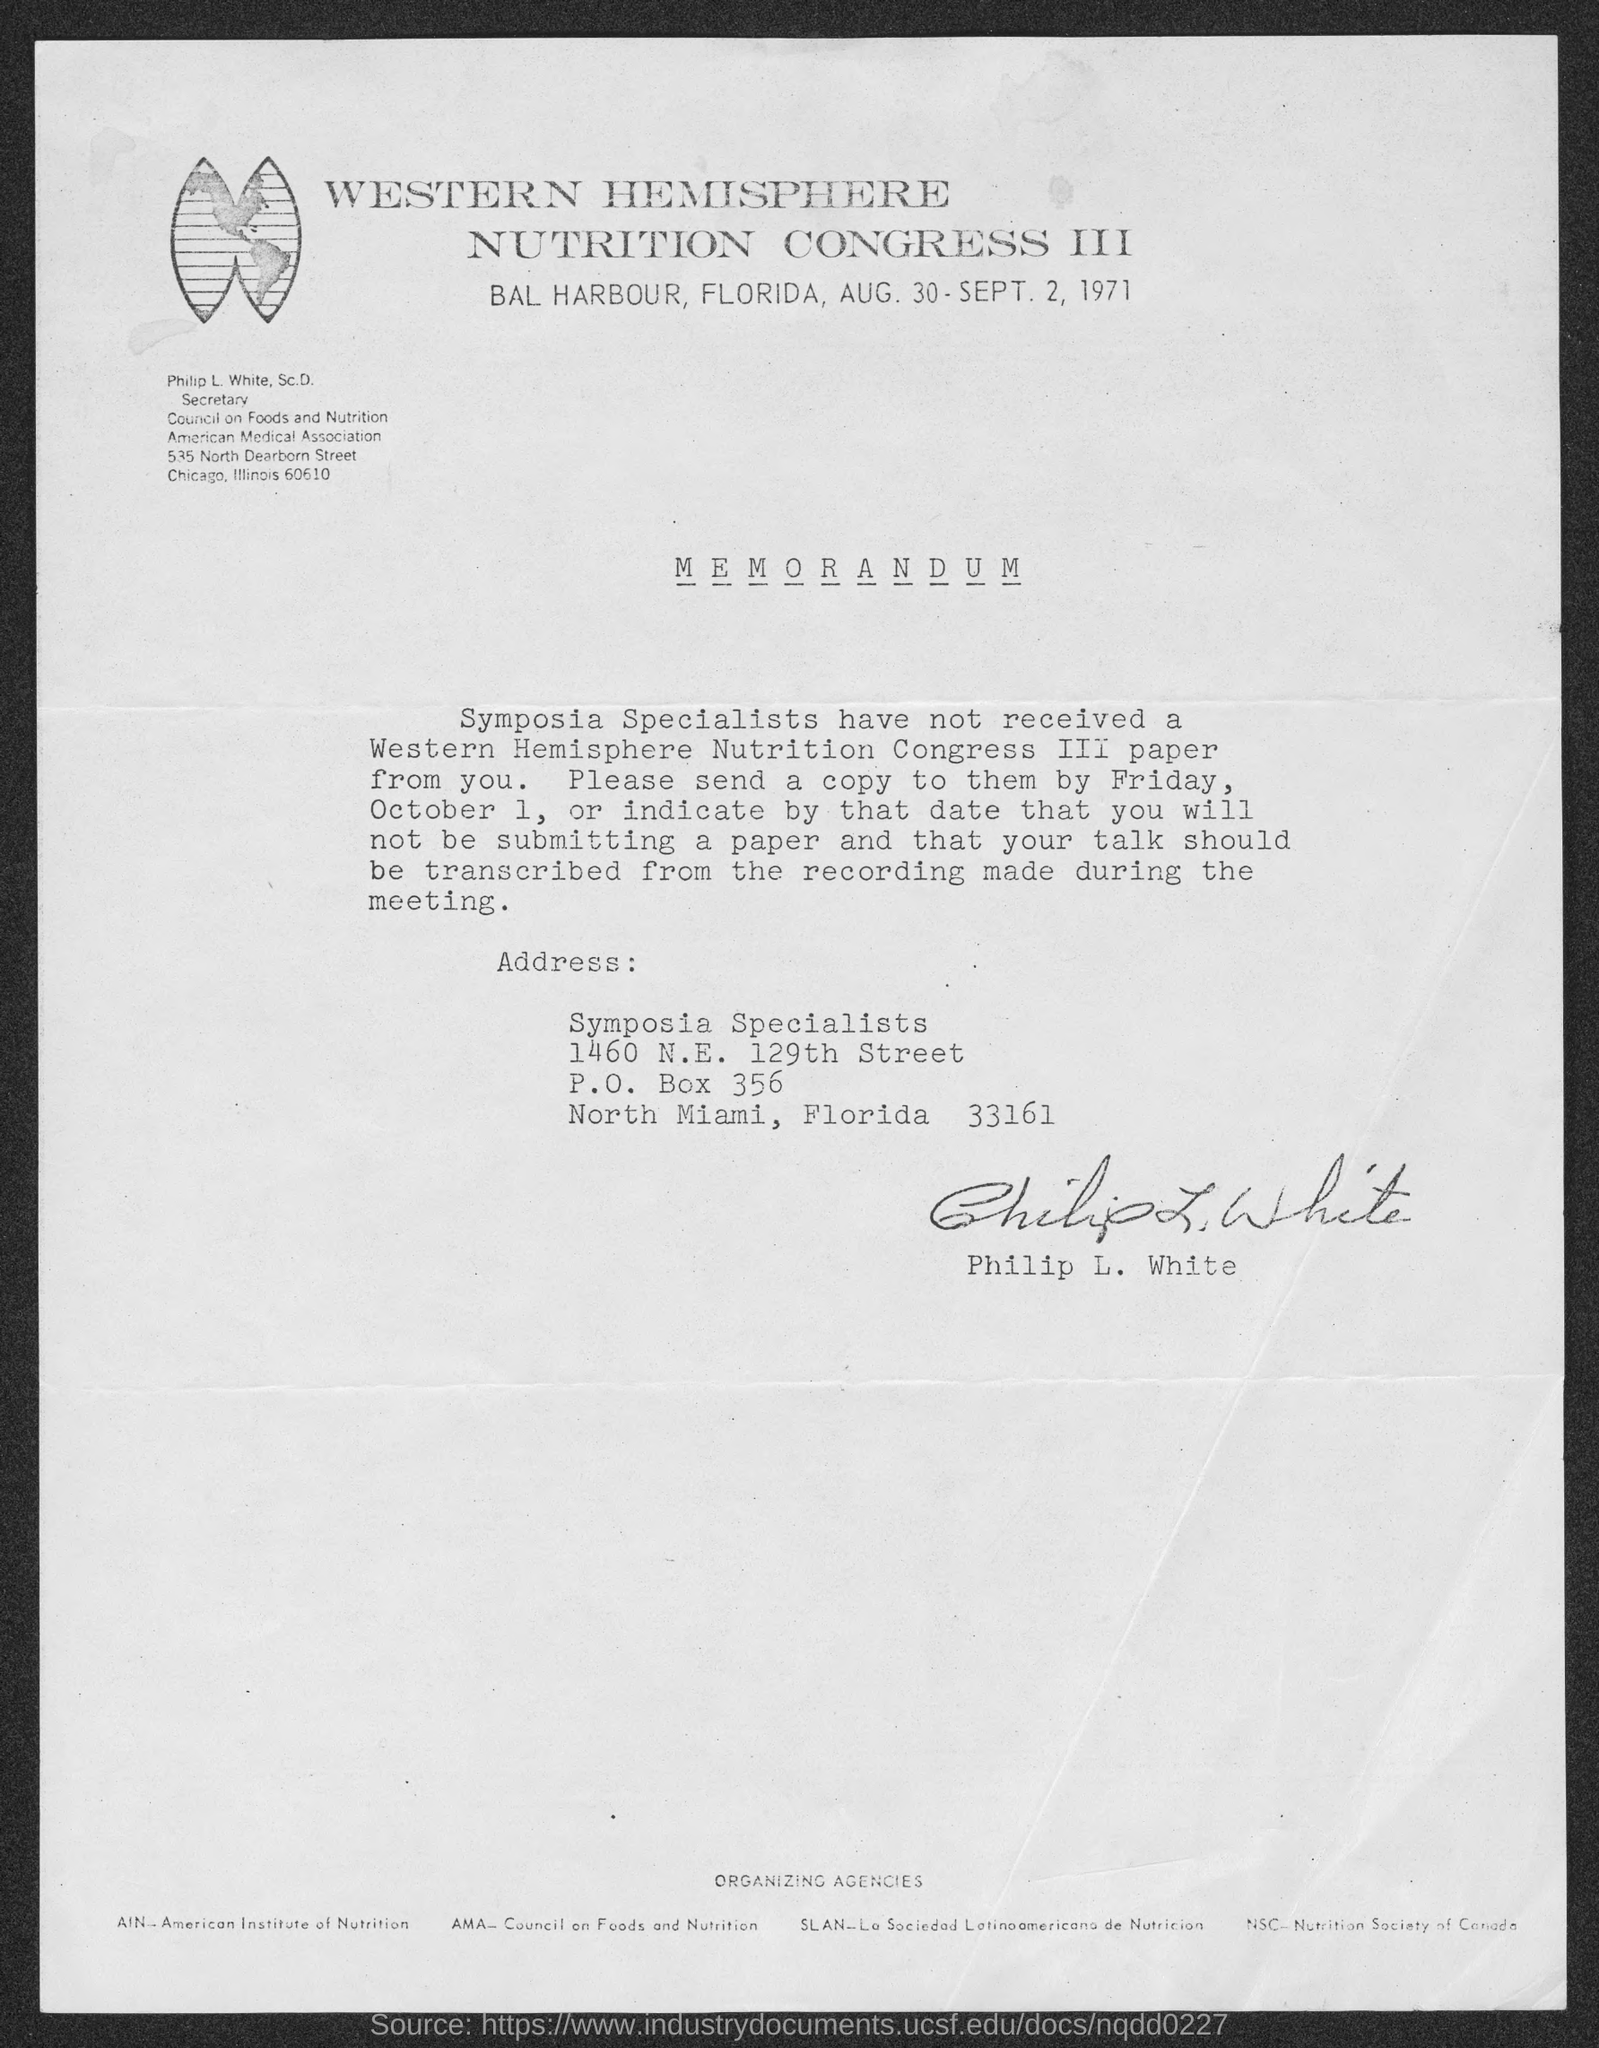Who has signed this memorandum?
Keep it short and to the point. Philip L. White. What is the designation of Philip L. White, Sc.D.?
Give a very brief answer. Secretary Council on Foods and Nutrition. 